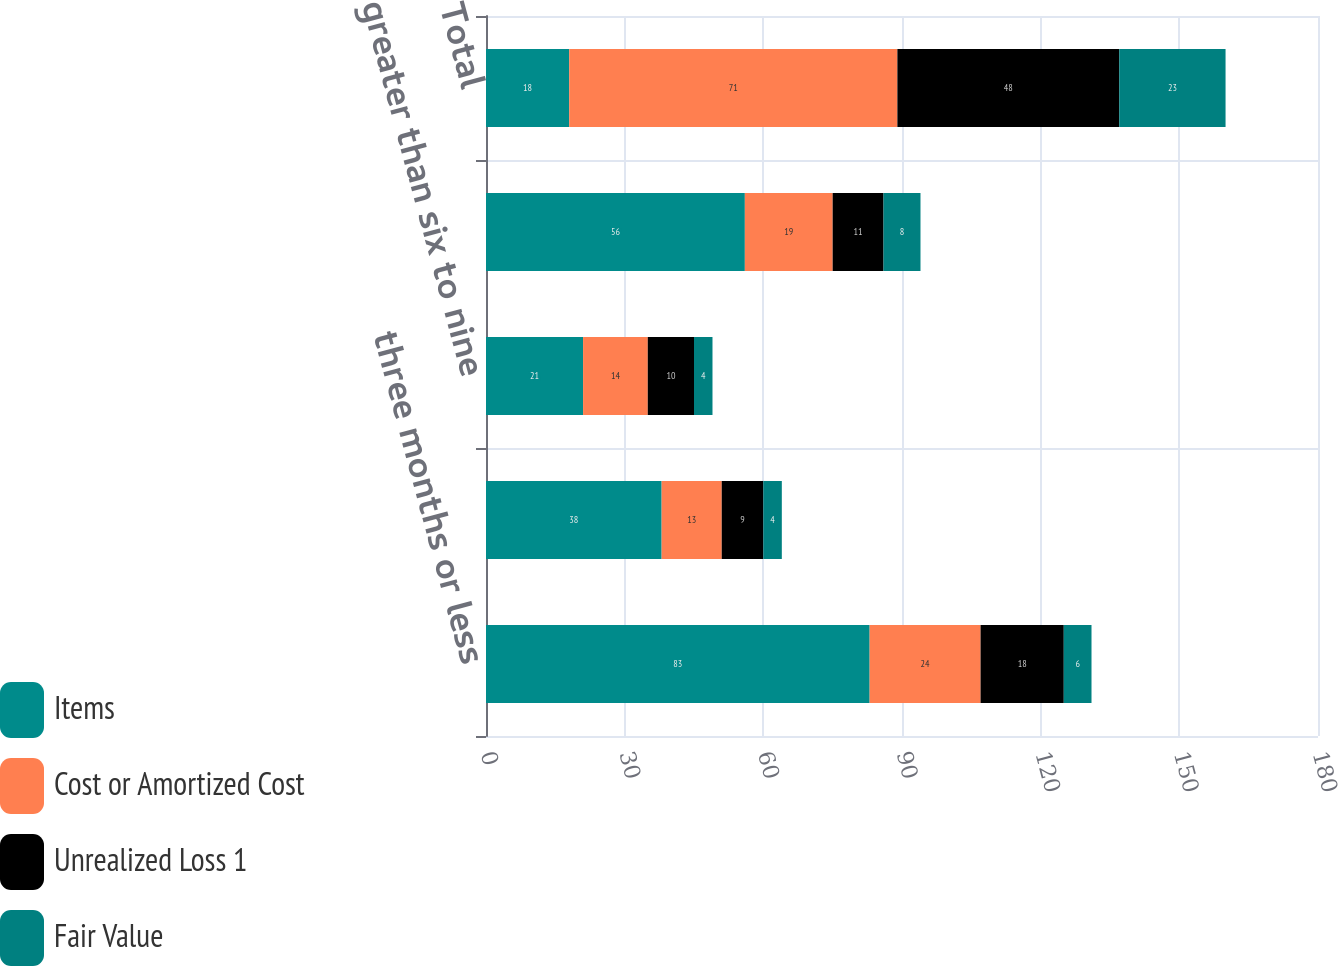Convert chart to OTSL. <chart><loc_0><loc_0><loc_500><loc_500><stacked_bar_chart><ecel><fcel>three months or less<fcel>greater than three to six<fcel>greater than six to nine<fcel>twelve months or more<fcel>Total<nl><fcel>Items<fcel>83<fcel>38<fcel>21<fcel>56<fcel>18<nl><fcel>Cost or Amortized Cost<fcel>24<fcel>13<fcel>14<fcel>19<fcel>71<nl><fcel>Unrealized Loss 1<fcel>18<fcel>9<fcel>10<fcel>11<fcel>48<nl><fcel>Fair Value<fcel>6<fcel>4<fcel>4<fcel>8<fcel>23<nl></chart> 